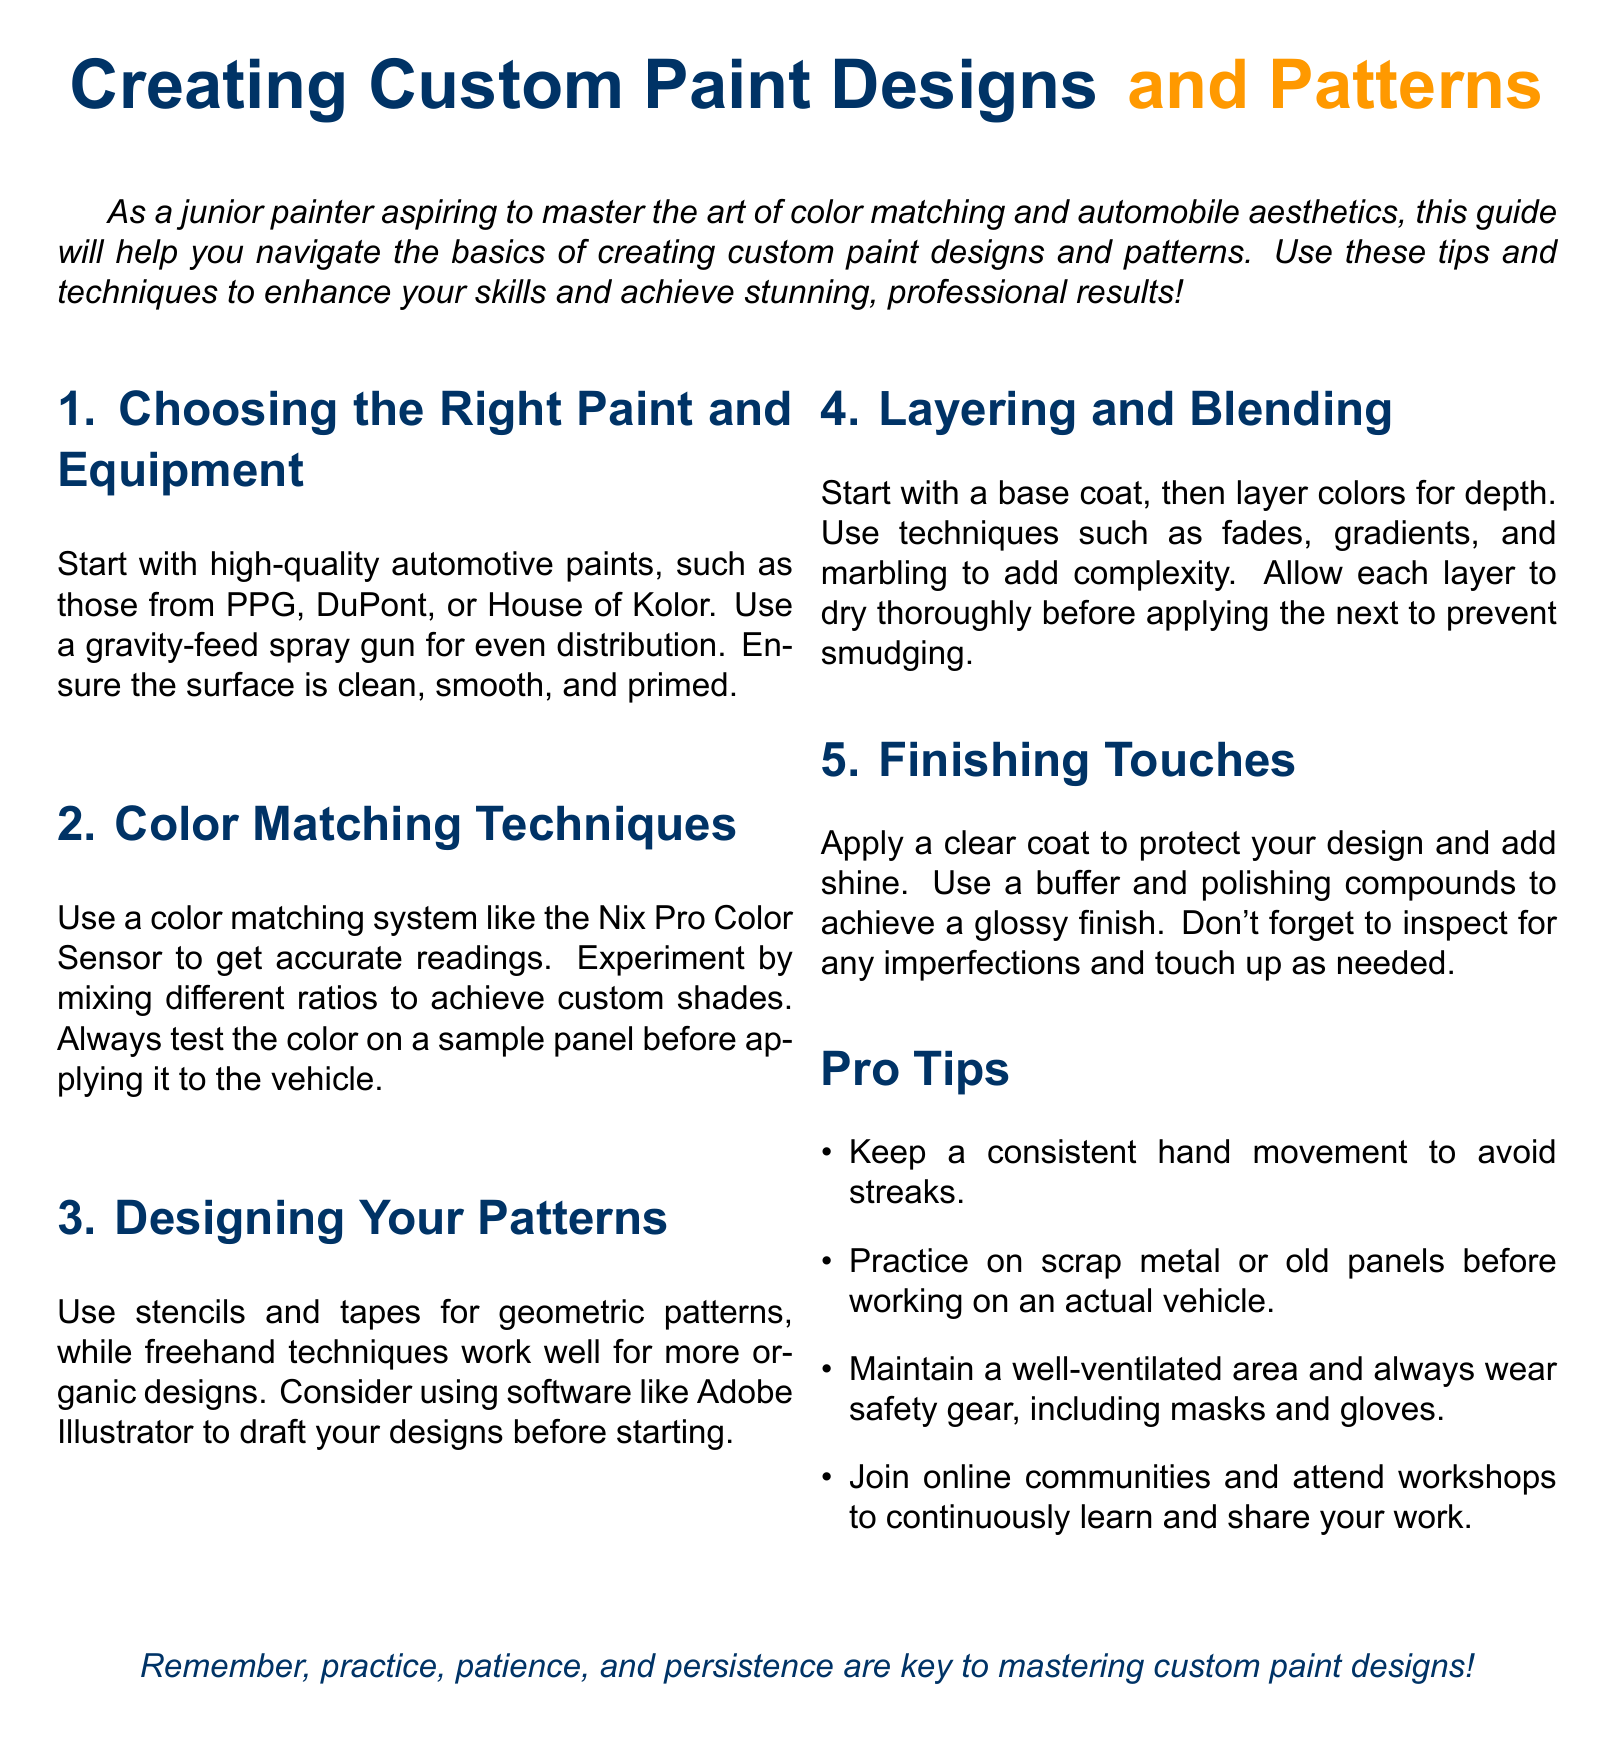What is the first step in creating custom paint designs? The first step is to choose high-quality automotive paints and ensure the surface is clean, smooth, and primed.
Answer: High-quality automotive paints What tools are recommended for designing patterns? The document suggests using stencils, tapes, and software like Adobe Illustrator for drafting designs.
Answer: Stencils, tapes, Adobe Illustrator Which type of spray gun is mentioned for even distribution? The guide mentions using a gravity-feed spray gun for even paint distribution.
Answer: Gravity-feed spray gun How should colors be tested before applying? Colors should be tested on a sample panel before applying them to the vehicle.
Answer: Sample panel What protective measure is advised when painting? The document advises wearing safety gear, including masks and gloves.
Answer: Masks and gloves What technique is suggested for adding depth to designs? Layering colors is suggested to add depth to the designs.
Answer: Layering colors What is an important step after applying the main design? Applying a clear coat is an important step after the main design.
Answer: Clear coat How many pro tips are listed in the document? The document lists a total of four pro tips.
Answer: Four What is emphasized as key to mastering custom paint designs? The document emphasizes practice, patience, and persistence.
Answer: Practice, patience, persistence 